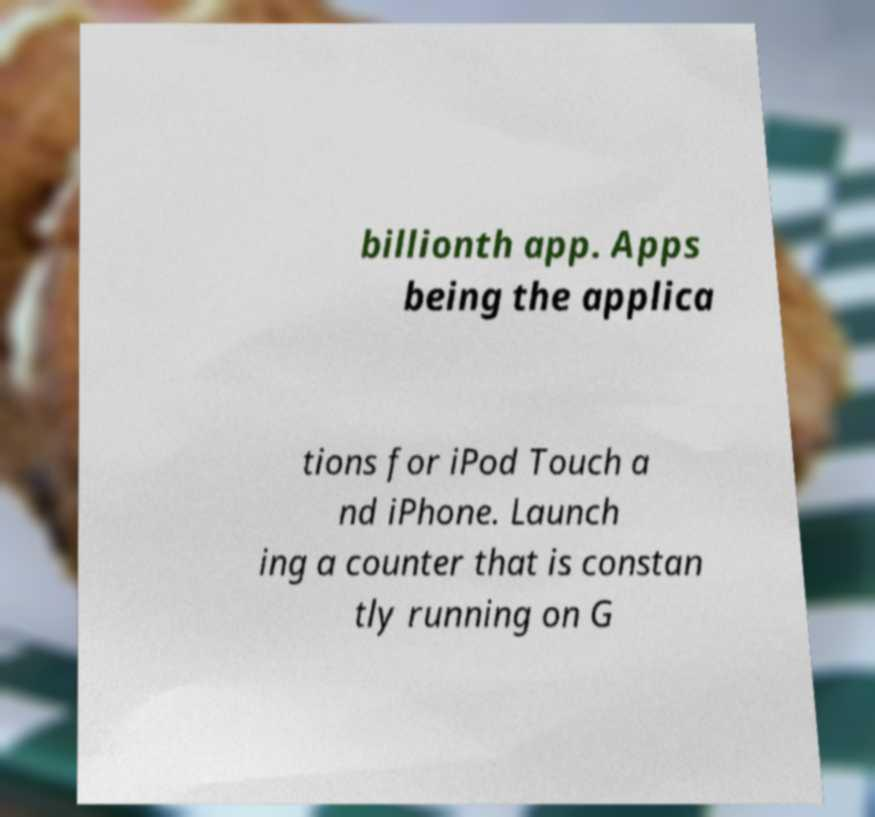I need the written content from this picture converted into text. Can you do that? billionth app. Apps being the applica tions for iPod Touch a nd iPhone. Launch ing a counter that is constan tly running on G 